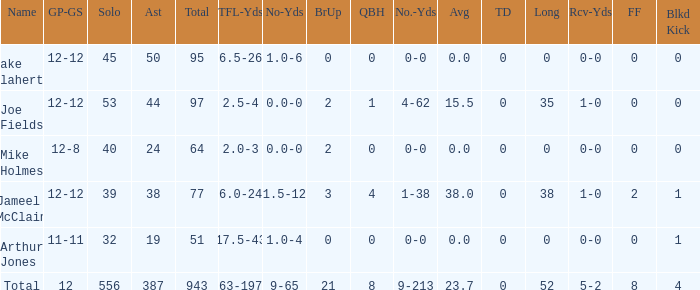How many yards for the player with tfl-yds of 2.5-4? 4-62. 